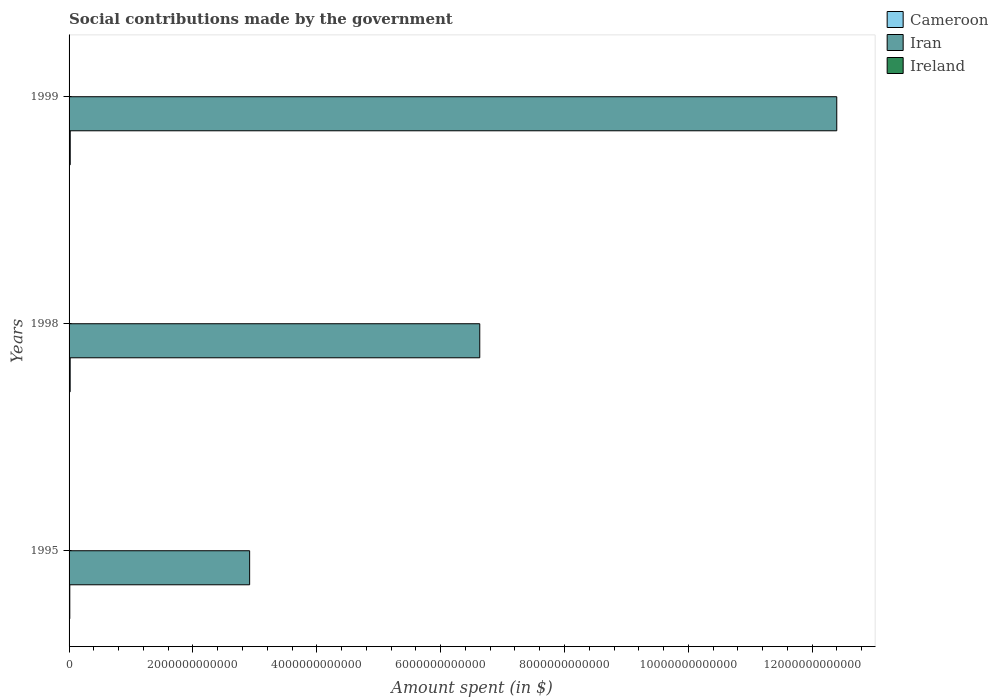How many different coloured bars are there?
Your answer should be compact. 3. How many bars are there on the 1st tick from the bottom?
Offer a very short reply. 3. In how many cases, is the number of bars for a given year not equal to the number of legend labels?
Make the answer very short. 0. What is the amount spent on social contributions in Cameroon in 1998?
Offer a terse response. 1.78e+1. Across all years, what is the maximum amount spent on social contributions in Cameroon?
Make the answer very short. 1.87e+1. Across all years, what is the minimum amount spent on social contributions in Ireland?
Give a very brief answer. 3.91e+09. What is the total amount spent on social contributions in Ireland in the graph?
Keep it short and to the point. 1.25e+1. What is the difference between the amount spent on social contributions in Ireland in 1995 and that in 1998?
Give a very brief answer. 1.72e+08. What is the difference between the amount spent on social contributions in Ireland in 1995 and the amount spent on social contributions in Iran in 1998?
Your response must be concise. -6.63e+12. What is the average amount spent on social contributions in Iran per year?
Make the answer very short. 7.31e+12. In the year 1999, what is the difference between the amount spent on social contributions in Ireland and amount spent on social contributions in Iran?
Give a very brief answer. -1.24e+13. What is the ratio of the amount spent on social contributions in Iran in 1995 to that in 1998?
Give a very brief answer. 0.44. Is the difference between the amount spent on social contributions in Ireland in 1998 and 1999 greater than the difference between the amount spent on social contributions in Iran in 1998 and 1999?
Make the answer very short. Yes. What is the difference between the highest and the second highest amount spent on social contributions in Ireland?
Ensure brevity in your answer.  4.66e+08. What is the difference between the highest and the lowest amount spent on social contributions in Ireland?
Your answer should be very brief. 6.38e+08. Is the sum of the amount spent on social contributions in Ireland in 1998 and 1999 greater than the maximum amount spent on social contributions in Cameroon across all years?
Offer a very short reply. No. What does the 1st bar from the top in 1999 represents?
Provide a short and direct response. Ireland. What does the 3rd bar from the bottom in 1998 represents?
Provide a short and direct response. Ireland. How many bars are there?
Offer a very short reply. 9. Are all the bars in the graph horizontal?
Make the answer very short. Yes. How many years are there in the graph?
Keep it short and to the point. 3. What is the difference between two consecutive major ticks on the X-axis?
Provide a succinct answer. 2.00e+12. Are the values on the major ticks of X-axis written in scientific E-notation?
Your answer should be very brief. No. What is the title of the graph?
Keep it short and to the point. Social contributions made by the government. Does "Papua New Guinea" appear as one of the legend labels in the graph?
Make the answer very short. No. What is the label or title of the X-axis?
Offer a terse response. Amount spent (in $). What is the Amount spent (in $) of Cameroon in 1995?
Provide a short and direct response. 1.17e+1. What is the Amount spent (in $) of Iran in 1995?
Offer a very short reply. 2.92e+12. What is the Amount spent (in $) in Ireland in 1995?
Your answer should be very brief. 4.08e+09. What is the Amount spent (in $) of Cameroon in 1998?
Your answer should be compact. 1.78e+1. What is the Amount spent (in $) in Iran in 1998?
Make the answer very short. 6.63e+12. What is the Amount spent (in $) of Ireland in 1998?
Your response must be concise. 3.91e+09. What is the Amount spent (in $) of Cameroon in 1999?
Ensure brevity in your answer.  1.87e+1. What is the Amount spent (in $) of Iran in 1999?
Your answer should be very brief. 1.24e+13. What is the Amount spent (in $) in Ireland in 1999?
Provide a succinct answer. 4.55e+09. Across all years, what is the maximum Amount spent (in $) of Cameroon?
Offer a terse response. 1.87e+1. Across all years, what is the maximum Amount spent (in $) of Iran?
Ensure brevity in your answer.  1.24e+13. Across all years, what is the maximum Amount spent (in $) in Ireland?
Provide a succinct answer. 4.55e+09. Across all years, what is the minimum Amount spent (in $) of Cameroon?
Your response must be concise. 1.17e+1. Across all years, what is the minimum Amount spent (in $) of Iran?
Keep it short and to the point. 2.92e+12. Across all years, what is the minimum Amount spent (in $) of Ireland?
Keep it short and to the point. 3.91e+09. What is the total Amount spent (in $) of Cameroon in the graph?
Make the answer very short. 4.82e+1. What is the total Amount spent (in $) in Iran in the graph?
Your response must be concise. 2.19e+13. What is the total Amount spent (in $) in Ireland in the graph?
Offer a very short reply. 1.25e+1. What is the difference between the Amount spent (in $) in Cameroon in 1995 and that in 1998?
Provide a succinct answer. -6.02e+09. What is the difference between the Amount spent (in $) of Iran in 1995 and that in 1998?
Your response must be concise. -3.72e+12. What is the difference between the Amount spent (in $) in Ireland in 1995 and that in 1998?
Offer a terse response. 1.72e+08. What is the difference between the Amount spent (in $) of Cameroon in 1995 and that in 1999?
Offer a very short reply. -6.98e+09. What is the difference between the Amount spent (in $) of Iran in 1995 and that in 1999?
Your answer should be compact. -9.48e+12. What is the difference between the Amount spent (in $) of Ireland in 1995 and that in 1999?
Make the answer very short. -4.66e+08. What is the difference between the Amount spent (in $) in Cameroon in 1998 and that in 1999?
Your response must be concise. -9.60e+08. What is the difference between the Amount spent (in $) of Iran in 1998 and that in 1999?
Provide a short and direct response. -5.76e+12. What is the difference between the Amount spent (in $) of Ireland in 1998 and that in 1999?
Offer a very short reply. -6.38e+08. What is the difference between the Amount spent (in $) in Cameroon in 1995 and the Amount spent (in $) in Iran in 1998?
Make the answer very short. -6.62e+12. What is the difference between the Amount spent (in $) in Cameroon in 1995 and the Amount spent (in $) in Ireland in 1998?
Make the answer very short. 7.82e+09. What is the difference between the Amount spent (in $) of Iran in 1995 and the Amount spent (in $) of Ireland in 1998?
Your answer should be compact. 2.91e+12. What is the difference between the Amount spent (in $) in Cameroon in 1995 and the Amount spent (in $) in Iran in 1999?
Give a very brief answer. -1.24e+13. What is the difference between the Amount spent (in $) of Cameroon in 1995 and the Amount spent (in $) of Ireland in 1999?
Provide a short and direct response. 7.18e+09. What is the difference between the Amount spent (in $) of Iran in 1995 and the Amount spent (in $) of Ireland in 1999?
Make the answer very short. 2.91e+12. What is the difference between the Amount spent (in $) in Cameroon in 1998 and the Amount spent (in $) in Iran in 1999?
Offer a very short reply. -1.24e+13. What is the difference between the Amount spent (in $) of Cameroon in 1998 and the Amount spent (in $) of Ireland in 1999?
Your answer should be very brief. 1.32e+1. What is the difference between the Amount spent (in $) in Iran in 1998 and the Amount spent (in $) in Ireland in 1999?
Ensure brevity in your answer.  6.63e+12. What is the average Amount spent (in $) in Cameroon per year?
Offer a very short reply. 1.61e+1. What is the average Amount spent (in $) of Iran per year?
Keep it short and to the point. 7.31e+12. What is the average Amount spent (in $) in Ireland per year?
Offer a terse response. 4.18e+09. In the year 1995, what is the difference between the Amount spent (in $) in Cameroon and Amount spent (in $) in Iran?
Your answer should be compact. -2.90e+12. In the year 1995, what is the difference between the Amount spent (in $) in Cameroon and Amount spent (in $) in Ireland?
Your answer should be very brief. 7.65e+09. In the year 1995, what is the difference between the Amount spent (in $) in Iran and Amount spent (in $) in Ireland?
Offer a terse response. 2.91e+12. In the year 1998, what is the difference between the Amount spent (in $) in Cameroon and Amount spent (in $) in Iran?
Keep it short and to the point. -6.61e+12. In the year 1998, what is the difference between the Amount spent (in $) of Cameroon and Amount spent (in $) of Ireland?
Your answer should be compact. 1.38e+1. In the year 1998, what is the difference between the Amount spent (in $) of Iran and Amount spent (in $) of Ireland?
Keep it short and to the point. 6.63e+12. In the year 1999, what is the difference between the Amount spent (in $) of Cameroon and Amount spent (in $) of Iran?
Make the answer very short. -1.24e+13. In the year 1999, what is the difference between the Amount spent (in $) in Cameroon and Amount spent (in $) in Ireland?
Give a very brief answer. 1.42e+1. In the year 1999, what is the difference between the Amount spent (in $) of Iran and Amount spent (in $) of Ireland?
Ensure brevity in your answer.  1.24e+13. What is the ratio of the Amount spent (in $) of Cameroon in 1995 to that in 1998?
Give a very brief answer. 0.66. What is the ratio of the Amount spent (in $) of Iran in 1995 to that in 1998?
Your response must be concise. 0.44. What is the ratio of the Amount spent (in $) in Ireland in 1995 to that in 1998?
Offer a terse response. 1.04. What is the ratio of the Amount spent (in $) of Cameroon in 1995 to that in 1999?
Offer a terse response. 0.63. What is the ratio of the Amount spent (in $) in Iran in 1995 to that in 1999?
Make the answer very short. 0.24. What is the ratio of the Amount spent (in $) in Ireland in 1995 to that in 1999?
Your answer should be compact. 0.9. What is the ratio of the Amount spent (in $) of Cameroon in 1998 to that in 1999?
Keep it short and to the point. 0.95. What is the ratio of the Amount spent (in $) in Iran in 1998 to that in 1999?
Provide a succinct answer. 0.54. What is the ratio of the Amount spent (in $) of Ireland in 1998 to that in 1999?
Provide a succinct answer. 0.86. What is the difference between the highest and the second highest Amount spent (in $) in Cameroon?
Offer a very short reply. 9.60e+08. What is the difference between the highest and the second highest Amount spent (in $) in Iran?
Your answer should be compact. 5.76e+12. What is the difference between the highest and the second highest Amount spent (in $) in Ireland?
Make the answer very short. 4.66e+08. What is the difference between the highest and the lowest Amount spent (in $) of Cameroon?
Give a very brief answer. 6.98e+09. What is the difference between the highest and the lowest Amount spent (in $) in Iran?
Your response must be concise. 9.48e+12. What is the difference between the highest and the lowest Amount spent (in $) in Ireland?
Make the answer very short. 6.38e+08. 